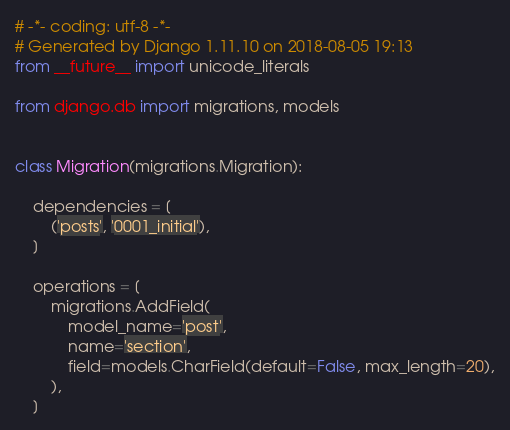Convert code to text. <code><loc_0><loc_0><loc_500><loc_500><_Python_># -*- coding: utf-8 -*-
# Generated by Django 1.11.10 on 2018-08-05 19:13
from __future__ import unicode_literals

from django.db import migrations, models


class Migration(migrations.Migration):

    dependencies = [
        ('posts', '0001_initial'),
    ]

    operations = [
        migrations.AddField(
            model_name='post',
            name='section',
            field=models.CharField(default=False, max_length=20),
        ),
    ]
</code> 